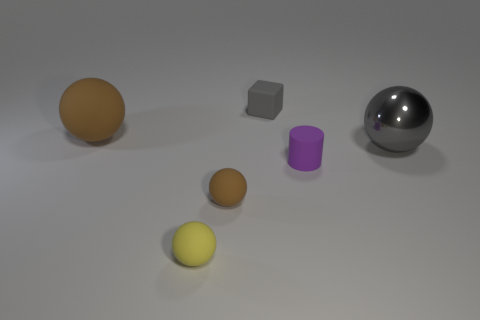Subtract all blue cylinders. How many brown balls are left? 2 Subtract all small yellow matte balls. How many balls are left? 3 Add 1 big metal balls. How many objects exist? 7 Subtract all brown spheres. How many spheres are left? 2 Subtract all gray spheres. Subtract all gray blocks. How many spheres are left? 3 Add 5 large gray balls. How many large gray balls are left? 6 Add 2 big brown matte objects. How many big brown matte objects exist? 3 Subtract 0 green blocks. How many objects are left? 6 Subtract all cylinders. How many objects are left? 5 Subtract all yellow things. Subtract all big brown objects. How many objects are left? 4 